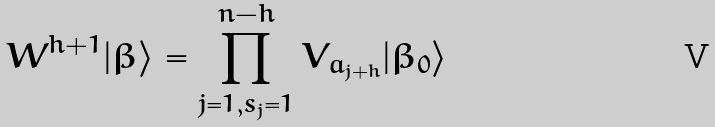Convert formula to latex. <formula><loc_0><loc_0><loc_500><loc_500>W ^ { h + 1 } | \beta \rangle = \prod _ { j = 1 , s _ { j } = 1 } ^ { n - h } V _ { a _ { j + h } } | \beta _ { 0 } \rangle</formula> 